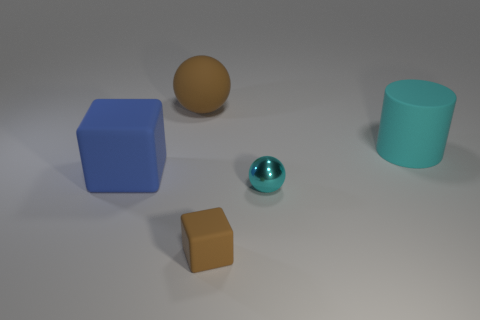There is a brown thing that is made of the same material as the brown cube; what shape is it?
Your response must be concise. Sphere. There is a cyan object in front of the cyan cylinder; is its shape the same as the cyan object behind the tiny metal sphere?
Your answer should be very brief. No. Are there fewer tiny metallic balls that are to the left of the large brown rubber sphere than cyan things that are on the left side of the cyan cylinder?
Provide a short and direct response. Yes. There is a thing that is the same color as the large matte ball; what shape is it?
Provide a succinct answer. Cube. How many cyan things have the same size as the blue block?
Your answer should be very brief. 1. Is the block that is behind the small shiny ball made of the same material as the brown sphere?
Offer a terse response. Yes. Are there any small cyan metal balls?
Provide a succinct answer. Yes. What size is the cyan thing that is made of the same material as the large sphere?
Give a very brief answer. Large. Is there a large ball that has the same color as the small shiny sphere?
Your response must be concise. No. Do the cube in front of the small ball and the matte cube that is behind the tiny brown matte cube have the same color?
Provide a short and direct response. No. 